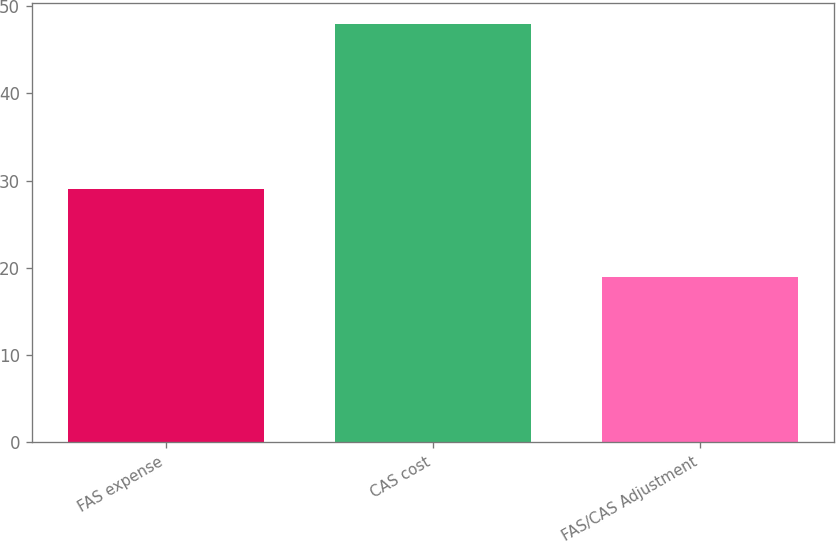<chart> <loc_0><loc_0><loc_500><loc_500><bar_chart><fcel>FAS expense<fcel>CAS cost<fcel>FAS/CAS Adjustment<nl><fcel>29<fcel>48<fcel>19<nl></chart> 